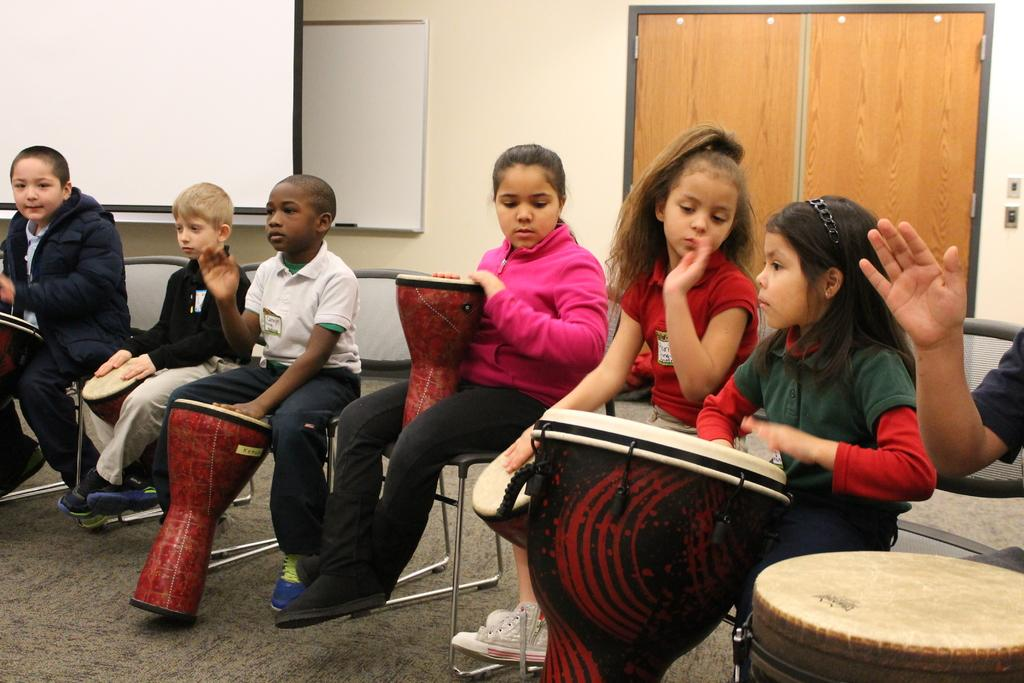What is the main subject of the image? The main subject of the image is a group of children. What are the children doing in the image? The children are sitting on chairs and playing musical instruments. What can be seen in the background of the image? There is a screen, a wall, and a door in the background of the image. What type of cub is sitting next to the children in the image? There is no cub present in the image; it features a group of children playing musical instruments. What kind of beast can be seen roaming around the children in the image? There is no beast present in the image; the children are sitting on chairs and playing musical instruments. 